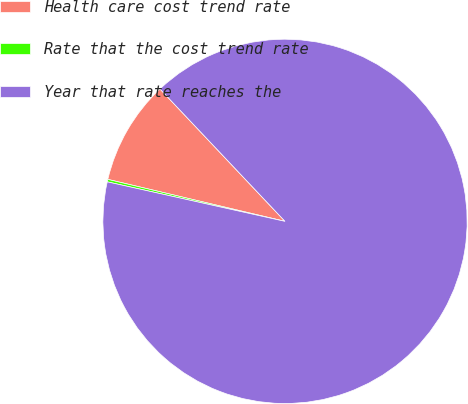<chart> <loc_0><loc_0><loc_500><loc_500><pie_chart><fcel>Health care cost trend rate<fcel>Rate that the cost trend rate<fcel>Year that rate reaches the<nl><fcel>9.25%<fcel>0.22%<fcel>90.52%<nl></chart> 